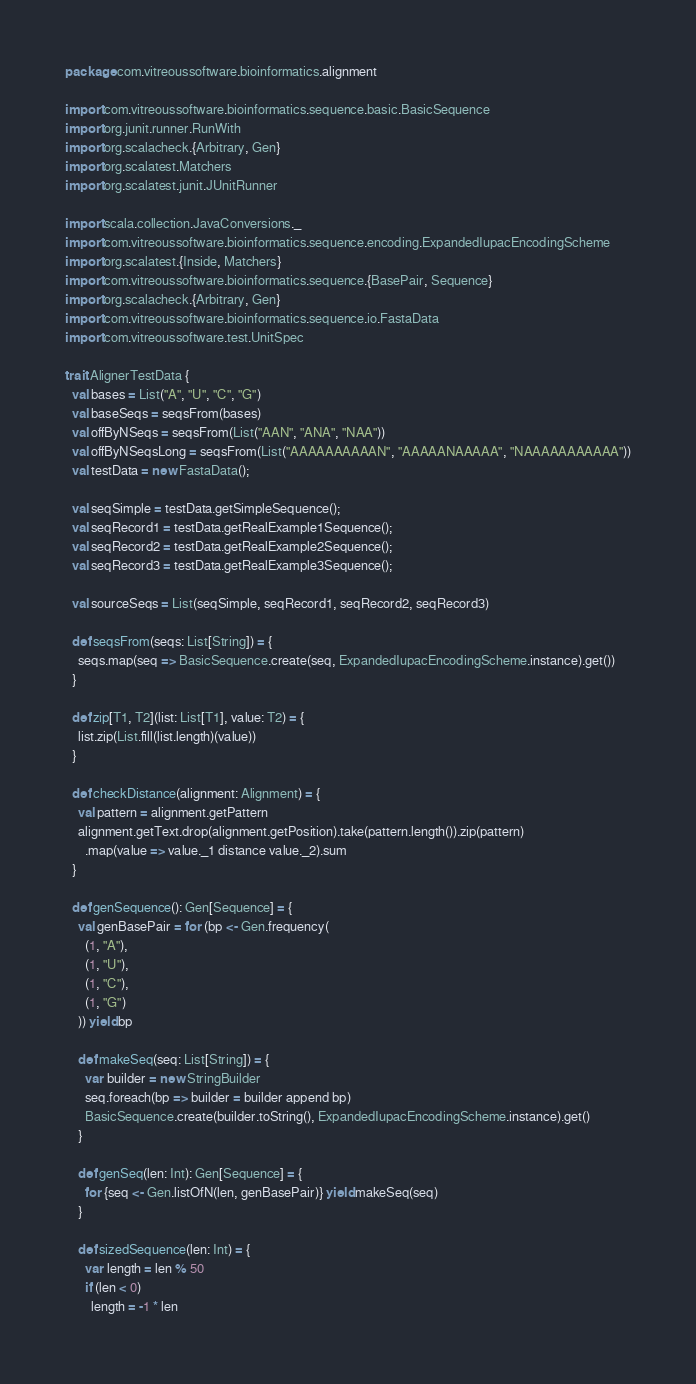Convert code to text. <code><loc_0><loc_0><loc_500><loc_500><_Scala_>package com.vitreoussoftware.bioinformatics.alignment

import com.vitreoussoftware.bioinformatics.sequence.basic.BasicSequence
import org.junit.runner.RunWith
import org.scalacheck.{Arbitrary, Gen}
import org.scalatest.Matchers
import org.scalatest.junit.JUnitRunner

import scala.collection.JavaConversions._
import com.vitreoussoftware.bioinformatics.sequence.encoding.ExpandedIupacEncodingScheme
import org.scalatest.{Inside, Matchers}
import com.vitreoussoftware.bioinformatics.sequence.{BasePair, Sequence}
import org.scalacheck.{Arbitrary, Gen}
import com.vitreoussoftware.bioinformatics.sequence.io.FastaData
import com.vitreoussoftware.test.UnitSpec

trait AlignerTestData {
  val bases = List("A", "U", "C", "G")
  val baseSeqs = seqsFrom(bases)
  val offByNSeqs = seqsFrom(List("AAN", "ANA", "NAA"))
  val offByNSeqsLong = seqsFrom(List("AAAAAAAAAAN", "AAAAANAAAAA", "NAAAAAAAAAAA"))
  val testData = new FastaData();

  val seqSimple = testData.getSimpleSequence();
  val seqRecord1 = testData.getRealExample1Sequence();
  val seqRecord2 = testData.getRealExample2Sequence();
  val seqRecord3 = testData.getRealExample3Sequence();

  val sourceSeqs = List(seqSimple, seqRecord1, seqRecord2, seqRecord3)

  def seqsFrom(seqs: List[String]) = {
    seqs.map(seq => BasicSequence.create(seq, ExpandedIupacEncodingScheme.instance).get())
  }

  def zip[T1, T2](list: List[T1], value: T2) = {
    list.zip(List.fill(list.length)(value))
  }

  def checkDistance(alignment: Alignment) = {
    val pattern = alignment.getPattern
    alignment.getText.drop(alignment.getPosition).take(pattern.length()).zip(pattern)
      .map(value => value._1 distance value._2).sum
  }

  def genSequence(): Gen[Sequence] = {
    val genBasePair = for (bp <- Gen.frequency(
      (1, "A"),
      (1, "U"),
      (1, "C"),
      (1, "G")
    )) yield bp

    def makeSeq(seq: List[String]) = {
      var builder = new StringBuilder
      seq.foreach(bp => builder = builder append bp)
      BasicSequence.create(builder.toString(), ExpandedIupacEncodingScheme.instance).get()
    }

    def genSeq(len: Int): Gen[Sequence] = {
      for {seq <- Gen.listOfN(len, genBasePair)} yield makeSeq(seq)
    }

    def sizedSequence(len: Int) = {
      var length = len % 50
      if (len < 0)
        length = -1 * len</code> 